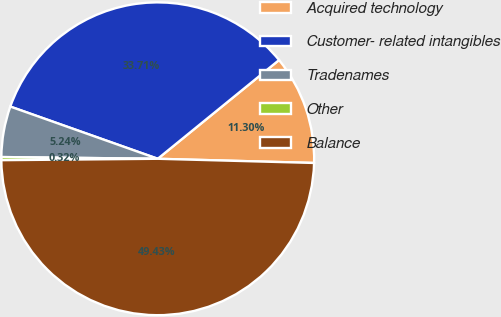Convert chart. <chart><loc_0><loc_0><loc_500><loc_500><pie_chart><fcel>Acquired technology<fcel>Customer- related intangibles<fcel>Tradenames<fcel>Other<fcel>Balance<nl><fcel>11.3%<fcel>33.71%<fcel>5.24%<fcel>0.32%<fcel>49.43%<nl></chart> 